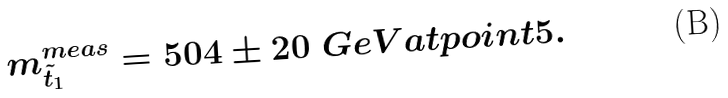<formula> <loc_0><loc_0><loc_500><loc_500>m _ { \tilde { t } _ { 1 } } ^ { m e a s } = 5 0 4 \pm 2 0 \ G e V a t p o i n t 5 .</formula> 